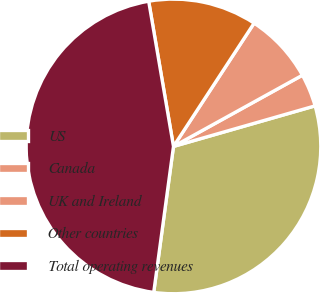Convert chart. <chart><loc_0><loc_0><loc_500><loc_500><pie_chart><fcel>US<fcel>Canada<fcel>UK and Ireland<fcel>Other countries<fcel>Total operating revenues<nl><fcel>31.58%<fcel>3.59%<fcel>7.75%<fcel>11.91%<fcel>45.16%<nl></chart> 